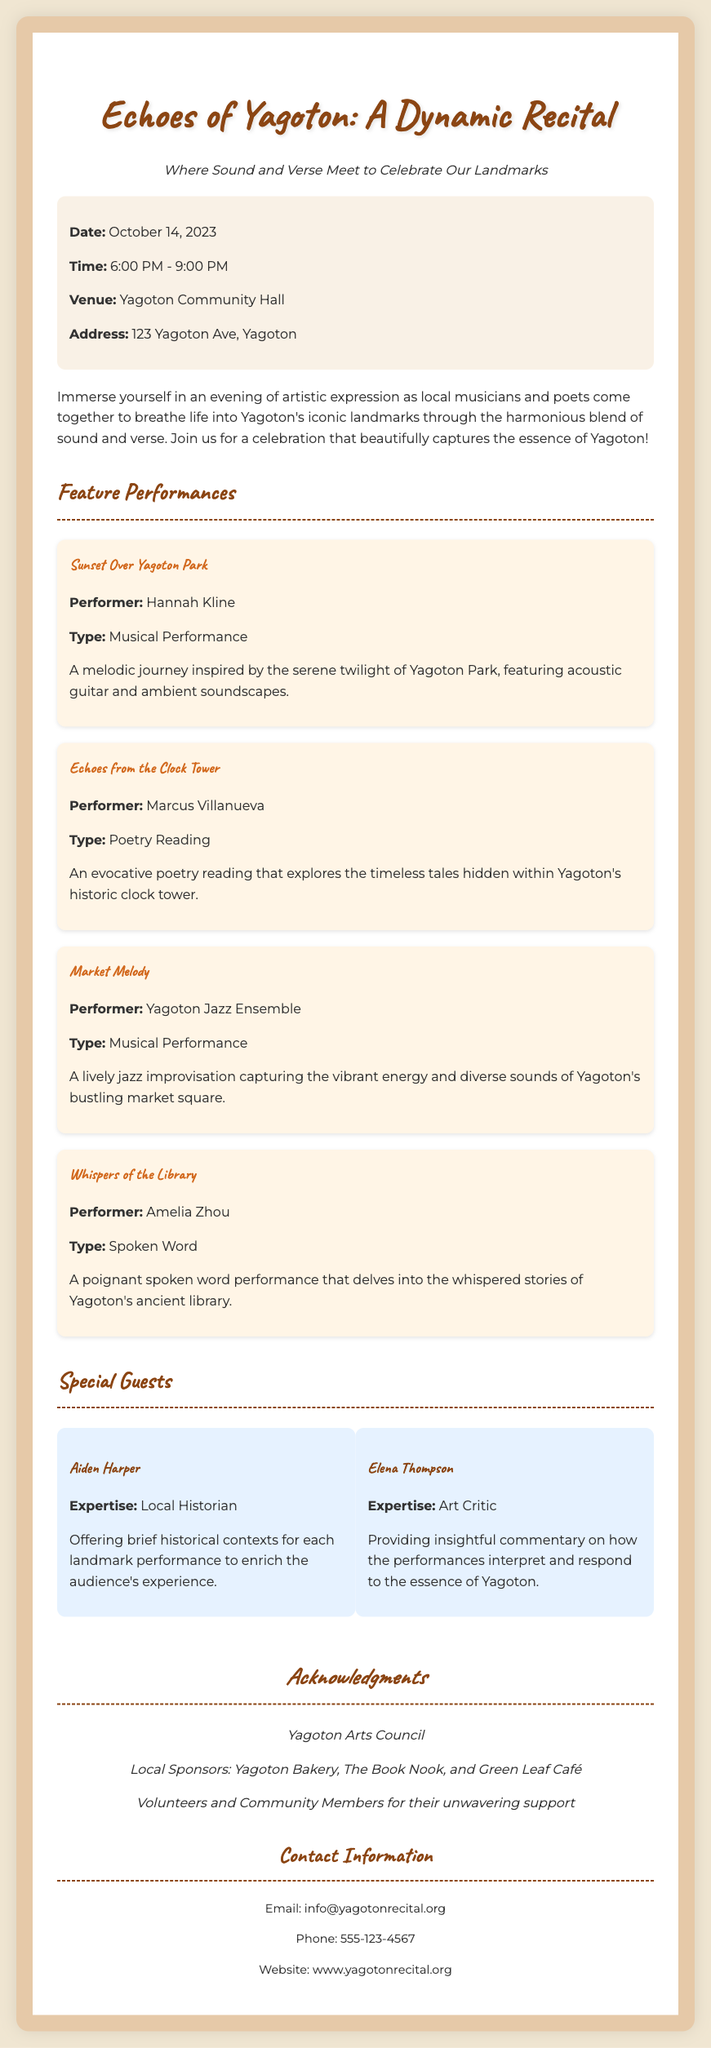What is the date of the recital? The date of the recital is clearly stated in the event details section of the document.
Answer: October 14, 2023 Who is the performer for 'Sunset Over Yagoton Park'? The document lists performers for each piece, and Hannah Kline is mentioned for this performance.
Answer: Hannah Kline What type of performance is 'Whispers of the Library'? The type of performance is specified in the description of each performance, indicating the format of the show.
Answer: Spoken Word What is the address of the venue? The address is included in the venue details, providing a specific location for attendees.
Answer: 123 Yagoton Ave, Yagoton What organization is acknowledged for their support? The acknowledgments section of the Playbill names the key organizations supporting the event.
Answer: Yagoton Arts Council What time does the recital start? The starting time for the event is provided in the event details section of the document.
Answer: 6:00 PM Who provides historical context during the recital? The special guests section identifies who will provide insights during the performances.
Answer: Aiden Harper How many performances are highlighted in the feature section? The feature performances section lists individual performances, allowing us to count how many there are.
Answer: Four 